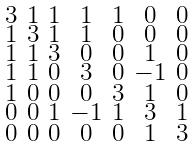<formula> <loc_0><loc_0><loc_500><loc_500>\begin{smallmatrix} 3 & 1 & 1 & 1 & 1 & 0 & 0 \\ 1 & 3 & 1 & 1 & 0 & 0 & 0 \\ 1 & 1 & 3 & 0 & 0 & 1 & 0 \\ 1 & 1 & 0 & 3 & 0 & - 1 & 0 \\ 1 & 0 & 0 & 0 & 3 & 1 & 0 \\ 0 & 0 & 1 & - 1 & 1 & 3 & 1 \\ 0 & 0 & 0 & 0 & 0 & 1 & 3 \end{smallmatrix}</formula> 